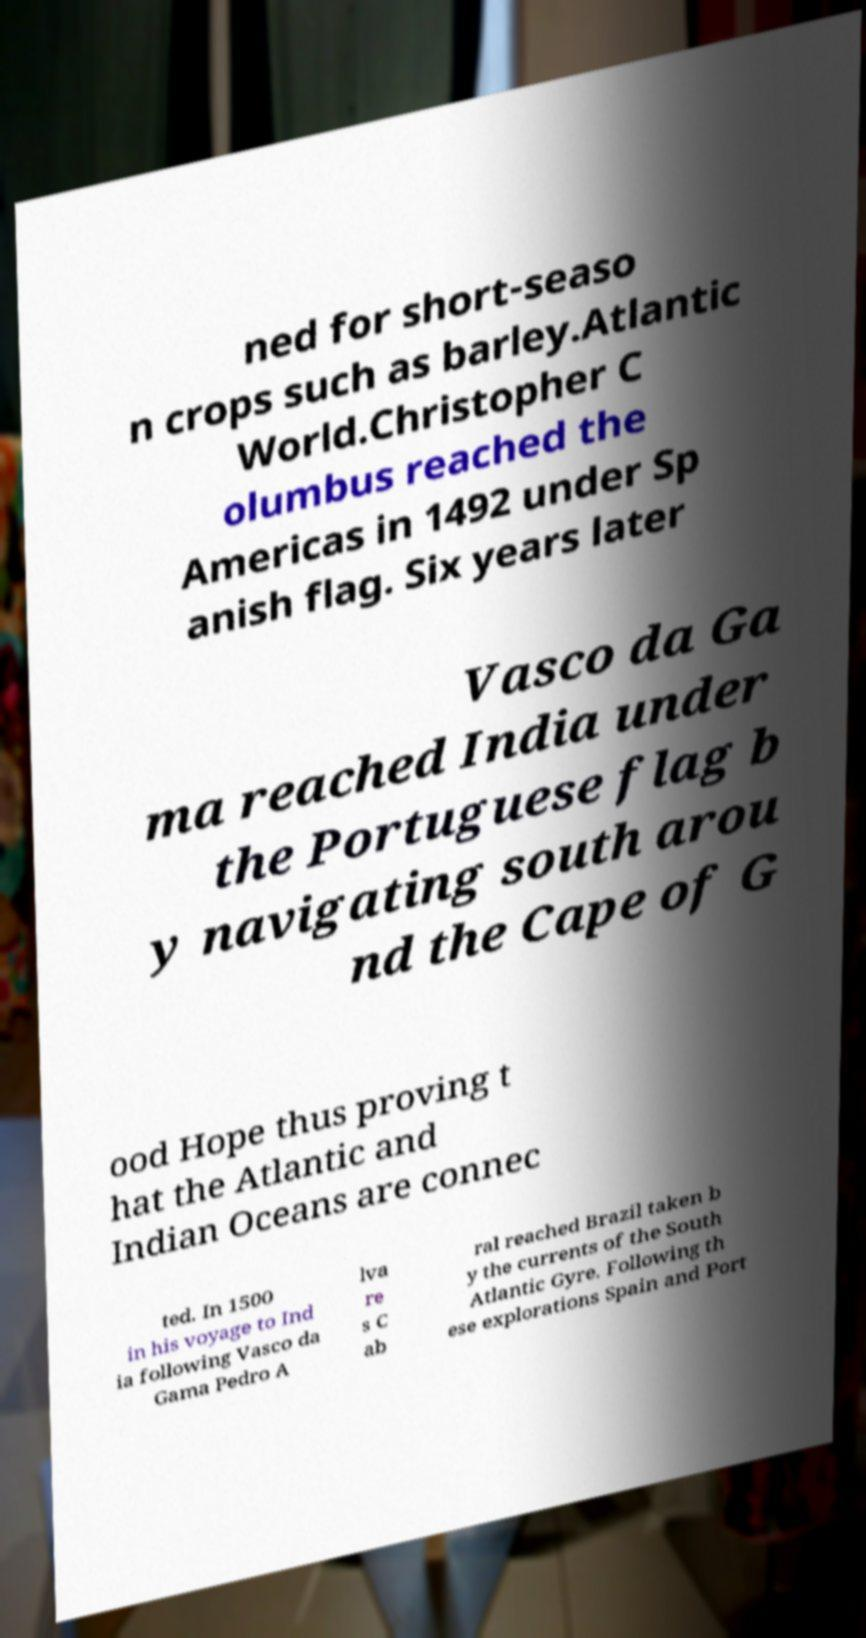For documentation purposes, I need the text within this image transcribed. Could you provide that? ned for short-seaso n crops such as barley.Atlantic World.Christopher C olumbus reached the Americas in 1492 under Sp anish flag. Six years later Vasco da Ga ma reached India under the Portuguese flag b y navigating south arou nd the Cape of G ood Hope thus proving t hat the Atlantic and Indian Oceans are connec ted. In 1500 in his voyage to Ind ia following Vasco da Gama Pedro A lva re s C ab ral reached Brazil taken b y the currents of the South Atlantic Gyre. Following th ese explorations Spain and Port 